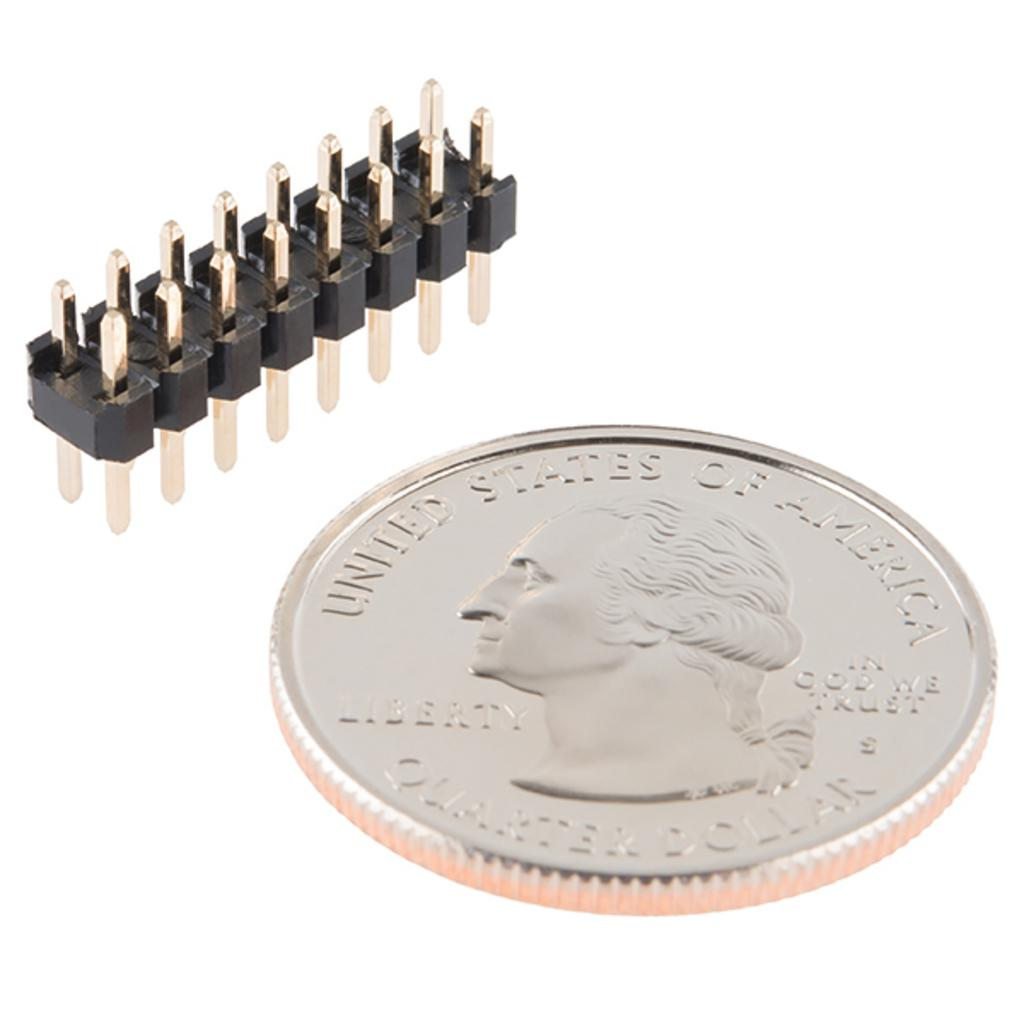What object can be seen in the picture? There is a coin in the picture. What is featured on the coin? There is text and a picture of a person on the coin. What other object is present in the image? There is an electric connector in the picture. What color is the background of the image? The background of the image is white. Can you tell me how many cups of corn are on the tramp in the image? There is no tramp or cup of corn present in the image; it only features a coin and an electric connector. 